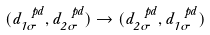Convert formula to latex. <formula><loc_0><loc_0><loc_500><loc_500>( d _ { 1 \sigma } ^ { \ p d } , d _ { 2 \sigma } ^ { \ p d } ) \rightarrow ( d _ { 2 \sigma } ^ { \ p d } , d _ { 1 \sigma } ^ { \ p d } )</formula> 